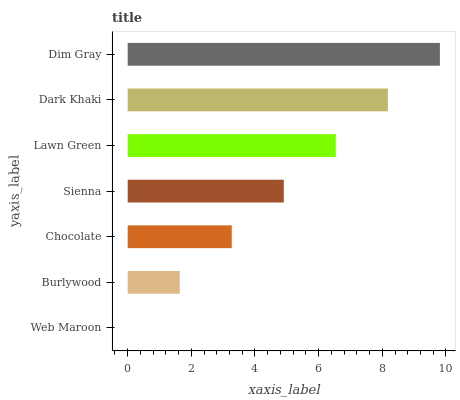Is Web Maroon the minimum?
Answer yes or no. Yes. Is Dim Gray the maximum?
Answer yes or no. Yes. Is Burlywood the minimum?
Answer yes or no. No. Is Burlywood the maximum?
Answer yes or no. No. Is Burlywood greater than Web Maroon?
Answer yes or no. Yes. Is Web Maroon less than Burlywood?
Answer yes or no. Yes. Is Web Maroon greater than Burlywood?
Answer yes or no. No. Is Burlywood less than Web Maroon?
Answer yes or no. No. Is Sienna the high median?
Answer yes or no. Yes. Is Sienna the low median?
Answer yes or no. Yes. Is Lawn Green the high median?
Answer yes or no. No. Is Web Maroon the low median?
Answer yes or no. No. 